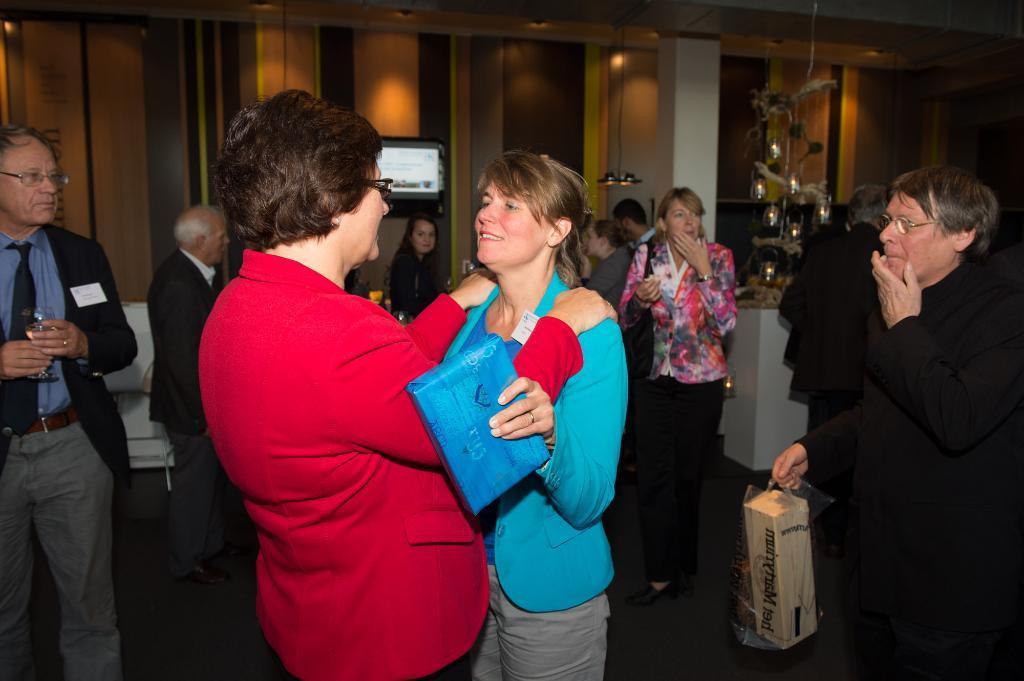Can you describe this image briefly? In this image I can see some people. In the background, I can see it looks like a board on the wall. At the top I can see the lights. 